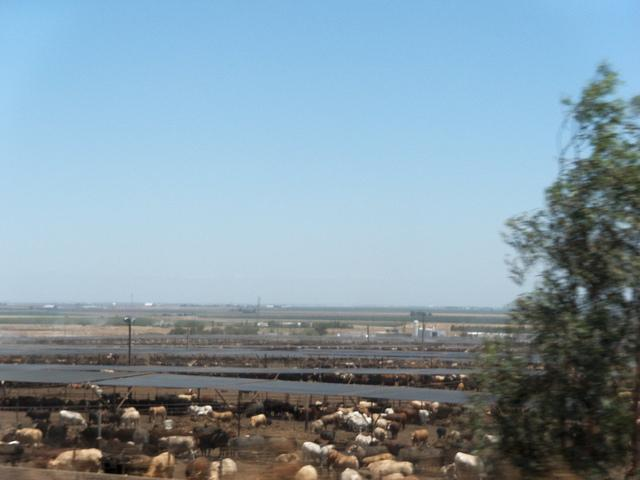What danger does the fence at the back of the lot protect the cows from?

Choices:
A) dehydration
B) insects
C) drowning
D) starving drowning 